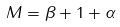Convert formula to latex. <formula><loc_0><loc_0><loc_500><loc_500>M = \beta + 1 + \alpha</formula> 